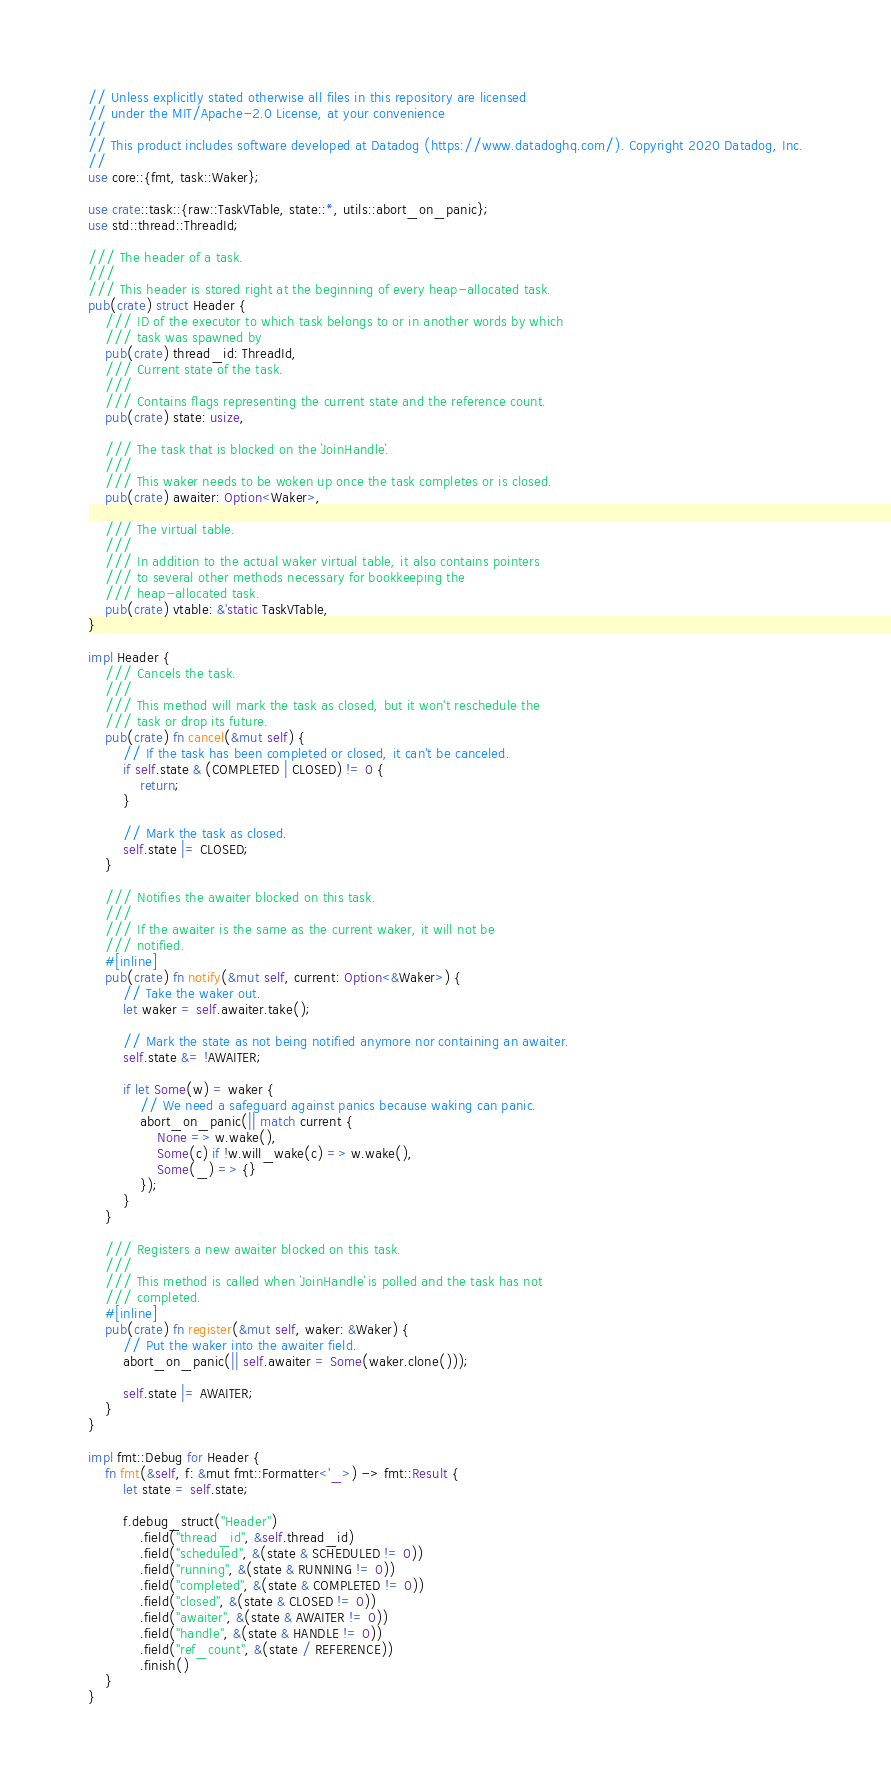Convert code to text. <code><loc_0><loc_0><loc_500><loc_500><_Rust_>// Unless explicitly stated otherwise all files in this repository are licensed
// under the MIT/Apache-2.0 License, at your convenience
//
// This product includes software developed at Datadog (https://www.datadoghq.com/). Copyright 2020 Datadog, Inc.
//
use core::{fmt, task::Waker};

use crate::task::{raw::TaskVTable, state::*, utils::abort_on_panic};
use std::thread::ThreadId;

/// The header of a task.
///
/// This header is stored right at the beginning of every heap-allocated task.
pub(crate) struct Header {
    /// ID of the executor to which task belongs to or in another words by which
    /// task was spawned by
    pub(crate) thread_id: ThreadId,
    /// Current state of the task.
    ///
    /// Contains flags representing the current state and the reference count.
    pub(crate) state: usize,

    /// The task that is blocked on the `JoinHandle`.
    ///
    /// This waker needs to be woken up once the task completes or is closed.
    pub(crate) awaiter: Option<Waker>,

    /// The virtual table.
    ///
    /// In addition to the actual waker virtual table, it also contains pointers
    /// to several other methods necessary for bookkeeping the
    /// heap-allocated task.
    pub(crate) vtable: &'static TaskVTable,
}

impl Header {
    /// Cancels the task.
    ///
    /// This method will mark the task as closed, but it won't reschedule the
    /// task or drop its future.
    pub(crate) fn cancel(&mut self) {
        // If the task has been completed or closed, it can't be canceled.
        if self.state & (COMPLETED | CLOSED) != 0 {
            return;
        }

        // Mark the task as closed.
        self.state |= CLOSED;
    }

    /// Notifies the awaiter blocked on this task.
    ///
    /// If the awaiter is the same as the current waker, it will not be
    /// notified.
    #[inline]
    pub(crate) fn notify(&mut self, current: Option<&Waker>) {
        // Take the waker out.
        let waker = self.awaiter.take();

        // Mark the state as not being notified anymore nor containing an awaiter.
        self.state &= !AWAITER;

        if let Some(w) = waker {
            // We need a safeguard against panics because waking can panic.
            abort_on_panic(|| match current {
                None => w.wake(),
                Some(c) if !w.will_wake(c) => w.wake(),
                Some(_) => {}
            });
        }
    }

    /// Registers a new awaiter blocked on this task.
    ///
    /// This method is called when `JoinHandle` is polled and the task has not
    /// completed.
    #[inline]
    pub(crate) fn register(&mut self, waker: &Waker) {
        // Put the waker into the awaiter field.
        abort_on_panic(|| self.awaiter = Some(waker.clone()));

        self.state |= AWAITER;
    }
}

impl fmt::Debug for Header {
    fn fmt(&self, f: &mut fmt::Formatter<'_>) -> fmt::Result {
        let state = self.state;

        f.debug_struct("Header")
            .field("thread_id", &self.thread_id)
            .field("scheduled", &(state & SCHEDULED != 0))
            .field("running", &(state & RUNNING != 0))
            .field("completed", &(state & COMPLETED != 0))
            .field("closed", &(state & CLOSED != 0))
            .field("awaiter", &(state & AWAITER != 0))
            .field("handle", &(state & HANDLE != 0))
            .field("ref_count", &(state / REFERENCE))
            .finish()
    }
}
</code> 